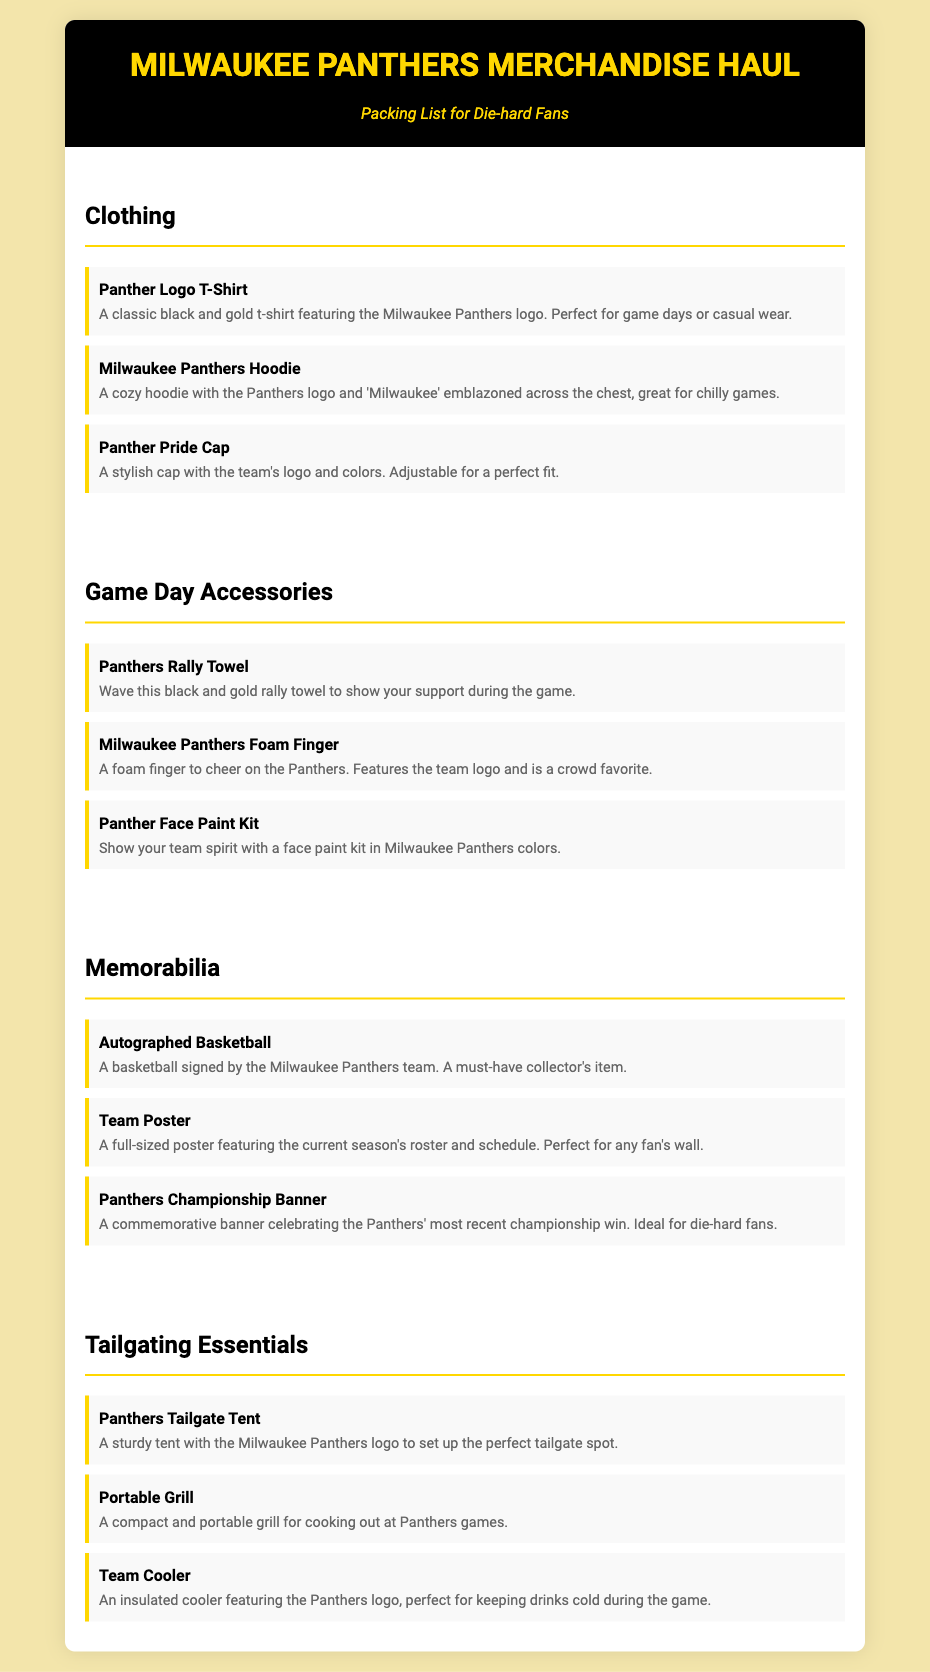What is the title of the document? The title of the document is prominently displayed at the top of the page as "Milwaukee Panthers Merchandise Haul."
Answer: Milwaukee Panthers Merchandise Haul How many clothing items are listed? The clothing section contains three individual items: the Panther Logo T-Shirt, Milwaukee Panthers Hoodie, and Panther Pride Cap.
Answer: 3 What is featured on the foam finger? The foam finger features the Milwaukee Panthers team logo.
Answer: team logo Which item serves as a collector's item? The autographed basketball is specified as a must-have collector's item in the memorabilia section.
Answer: Autographed Basketball What color is the Panthers Tailgate Tent? The Panthers Tailgate Tent has the Milwaukee Panthers logo, which features black and gold colors.
Answer: black and gold Which type of item includes a paint kit? The Panther Face Paint Kit is categorized as a game day accessory for displaying team spirit.
Answer: game day accessory What is the purpose of the Team Cooler? The Team Cooler is designed to keep drinks cold during the game, indicating its use for tailgating.
Answer: keeping drinks cold What season does the Team Poster feature? The Team Poster features the current season's roster and schedule, thus relating to the ongoing season.
Answer: current season Which item is specifically for chilly games? The Milwaukee Panthers Hoodie is noted for being great for chilly games, indicating its warmth and comfort.
Answer: Milwaukee Panthers Hoodie 